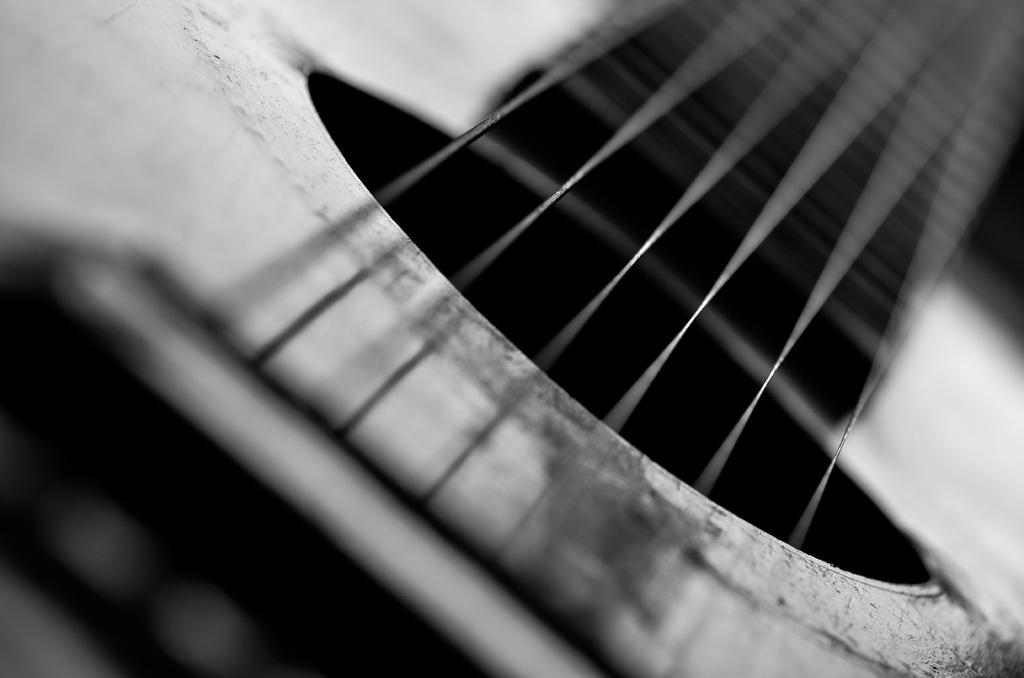Can you describe this image briefly? In the picture I can see a closer view of the guitar and I can see the strings of the guitar. 